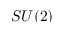Convert formula to latex. <formula><loc_0><loc_0><loc_500><loc_500>S U ( 2 )</formula> 